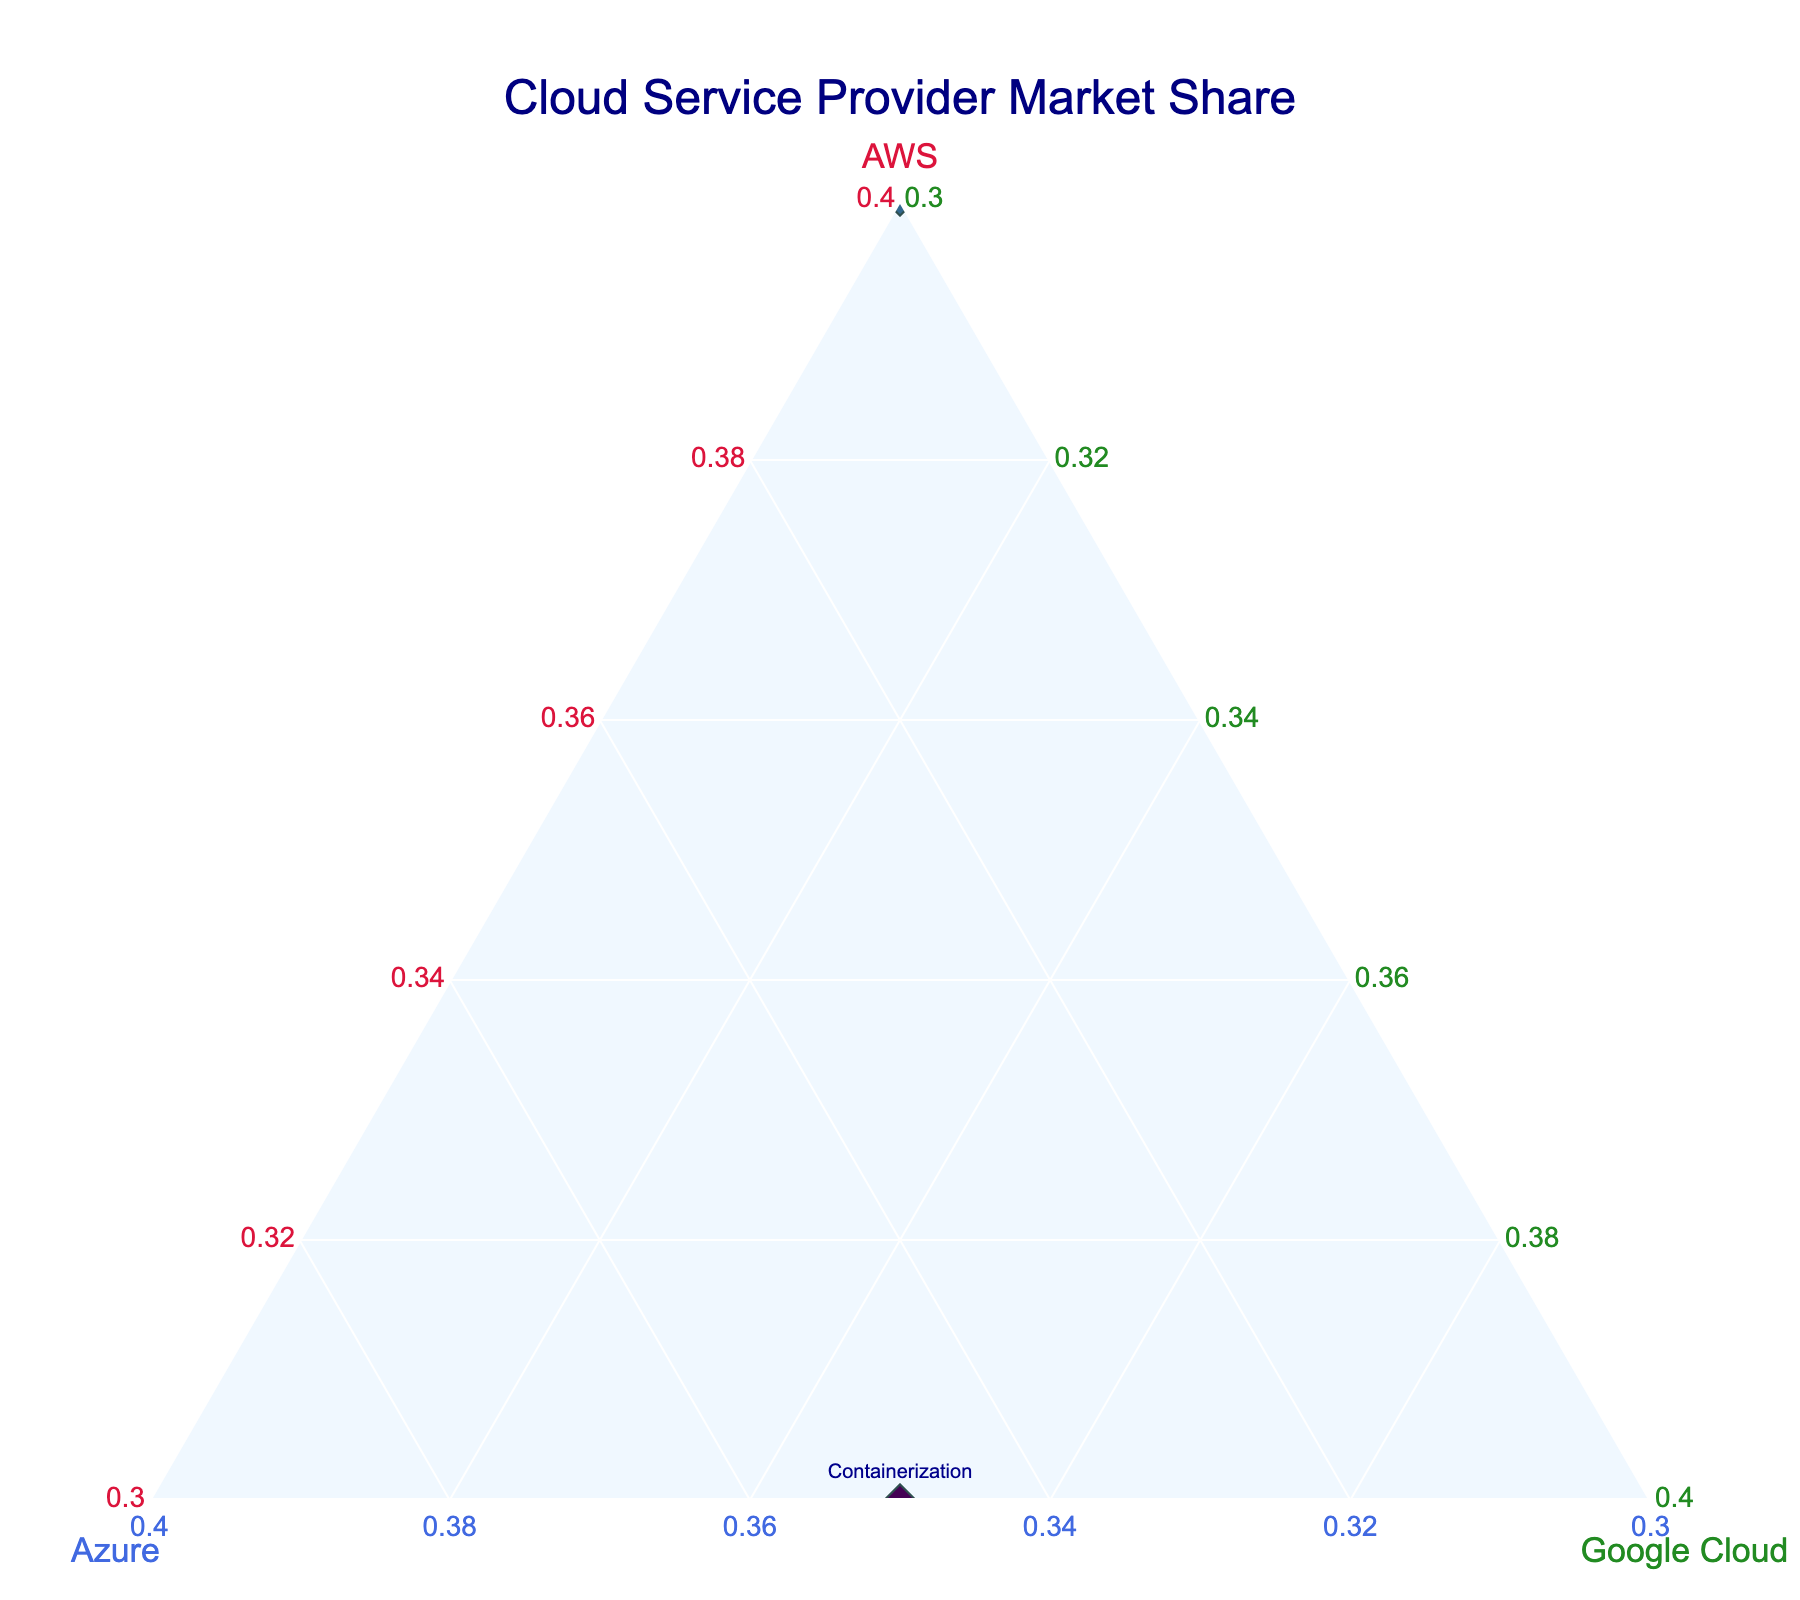What is the title of the figure? The title is typically the most prominent text at the top of the figure.
Answer: Cloud Service Provider Market Share What colors represent the three cloud providers' shares on the ternary plot? The colors of the axis titles and text are typically distinct and mentioned within the design guidelines or legends.
Answer: Crimson for AWS, Royal Blue for Azure, Forest Green for Google Cloud How many projects are represented in the figure? To find the number of projects, you count the number of markers (each representing a project) in the plot
Answer: 10 What is the average market share of AWS across all projects? Sum the AWS shares for all projects and divide by the number of projects: (45+60+30+40+55+35+50+40+30+45) / 10
Answer: 43% What is the total market share for 'Web Hosting' and 'Microservices Architecture' projects for Azure? Sum the Azure market share for the two mentioned projects. They share 25% and 45%, so 25+45 = 70%
Answer: 70% Which project has the highest market share for Azure? Identify the project with the largest value on the Azure axis. The 'Big Data Analytics' project has 50% which is the highest for Azure
Answer: Big Data Analytics Are there any projects where Google Cloud's market share is higher than Azure’s? Compare the values of Google Cloud and Azure shares for each project to see if any of Google's values exceed Azure's. In the 'Containerization' project, Google Cloud has 35% and Azure has 35%, which means no project has Google Cloud’s share higher than Azure’s.
Answer: No Which cloud provider dominates the 'Serverless Computing' project? Find the highest value among AWS, Azure, and Google Cloud for the 'Serverless Computing' Project. AWS has 55%, which is higher than Azure's 30% and Google Cloud's 15%.
Answer: AWS How does the balance of market share compare between 'Machine Learning Platform' and 'Database Migration' projects? Compare the proportions of AWS, Azure, and Google Cloud for the two projects. 'Machine Learning Platform' shows AWS: 35%, Azure: 40%, Google Cloud: 25%. 'Database Migration' shows AWS: 45%, Azure: 35%, Google Cloud: 20%. So, 'Database Migration' has AWS leading by a wider margin compared to Azure and Google Cloud.
Answer: 'Database Migration' is more AWS-dominated Which project marker is closest to the center of the ternary plot, indicating a more balanced market share among the providers? Identify the marker that is closest to the center (which would mean all three providers have approximately equal shares). The 'DevOps Pipeline' with shares AWS: 40%, Azure: 30%, Google Cloud: 30% is closest to being balanced.
Answer: DevOps Pipeline 